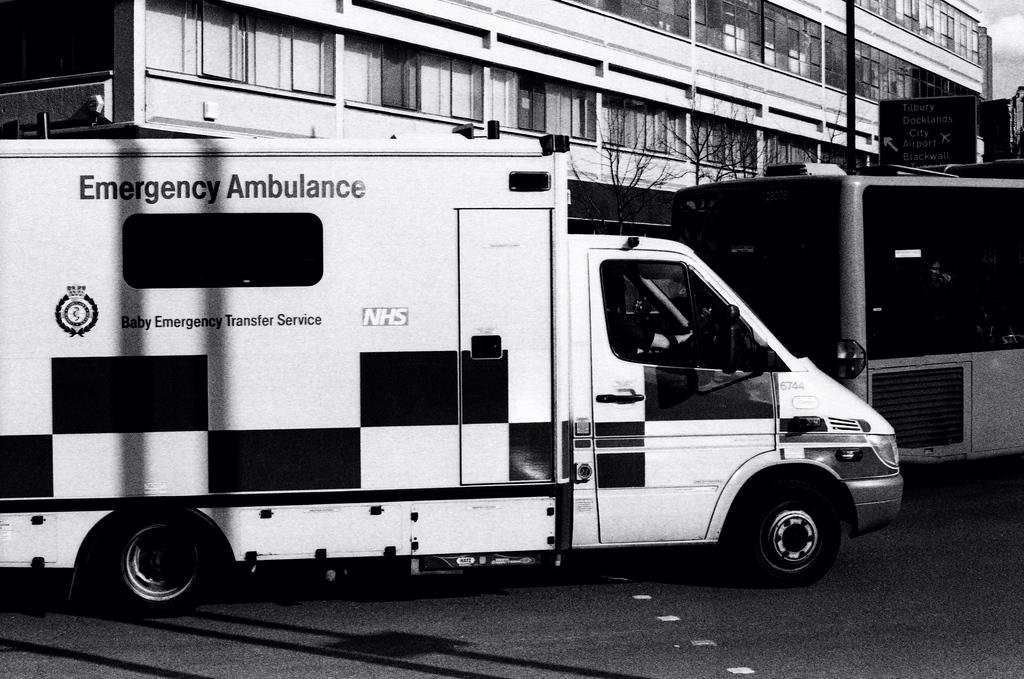What is the color scheme of the image? The image is black and white. What can be seen on the road in the image? There is an ambulance on the road. What is located behind the ambulance in the image? There is a building behind the ambulance. What is near the building in the image? There is a tree near the building. What is in front of the building in the image? There is a bus in front of the building. What is the name of the playground in the image? There is no playground present in the image. How does the sorting process work for the items in the image? The image does not depict any sorting process, as it features an ambulance, a building, a tree, and a bus. 